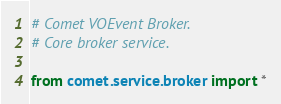<code> <loc_0><loc_0><loc_500><loc_500><_Python_># Comet VOEvent Broker.
# Core broker service.

from comet.service.broker import *
</code> 